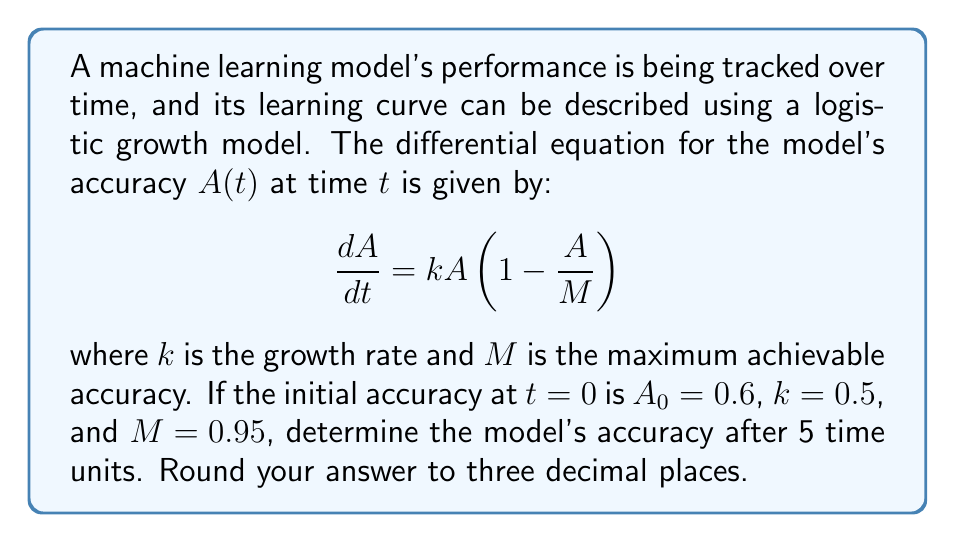Show me your answer to this math problem. To solve this problem, we need to follow these steps:

1) The given differential equation is a logistic growth model. Its solution is:

   $$A(t) = \frac{M}{1 + (\frac{M}{A_0} - 1)e^{-kt}}$$

2) We are given the following values:
   - $A_0 = 0.6$ (initial accuracy)
   - $k = 0.5$ (growth rate)
   - $M = 0.95$ (maximum achievable accuracy)
   - $t = 5$ (time units)

3) Let's substitute these values into the equation:

   $$A(5) = \frac{0.95}{1 + (\frac{0.95}{0.6} - 1)e^{-0.5(5)}}$$

4) First, let's calculate $\frac{0.95}{0.6} - 1$:
   
   $$\frac{0.95}{0.6} - 1 = 1.5833 - 1 = 0.5833$$

5) Now our equation looks like:

   $$A(5) = \frac{0.95}{1 + 0.5833e^{-2.5}}$$

6) Calculate $e^{-2.5}$:
   
   $$e^{-2.5} \approx 0.0821$$

7) Substitute this back:

   $$A(5) = \frac{0.95}{1 + 0.5833(0.0821)} = \frac{0.95}{1 + 0.0479}$$

8) Simplify:

   $$A(5) = \frac{0.95}{1.0479} \approx 0.9066$$

9) Rounding to three decimal places:

   $$A(5) \approx 0.907$$
Answer: 0.907 